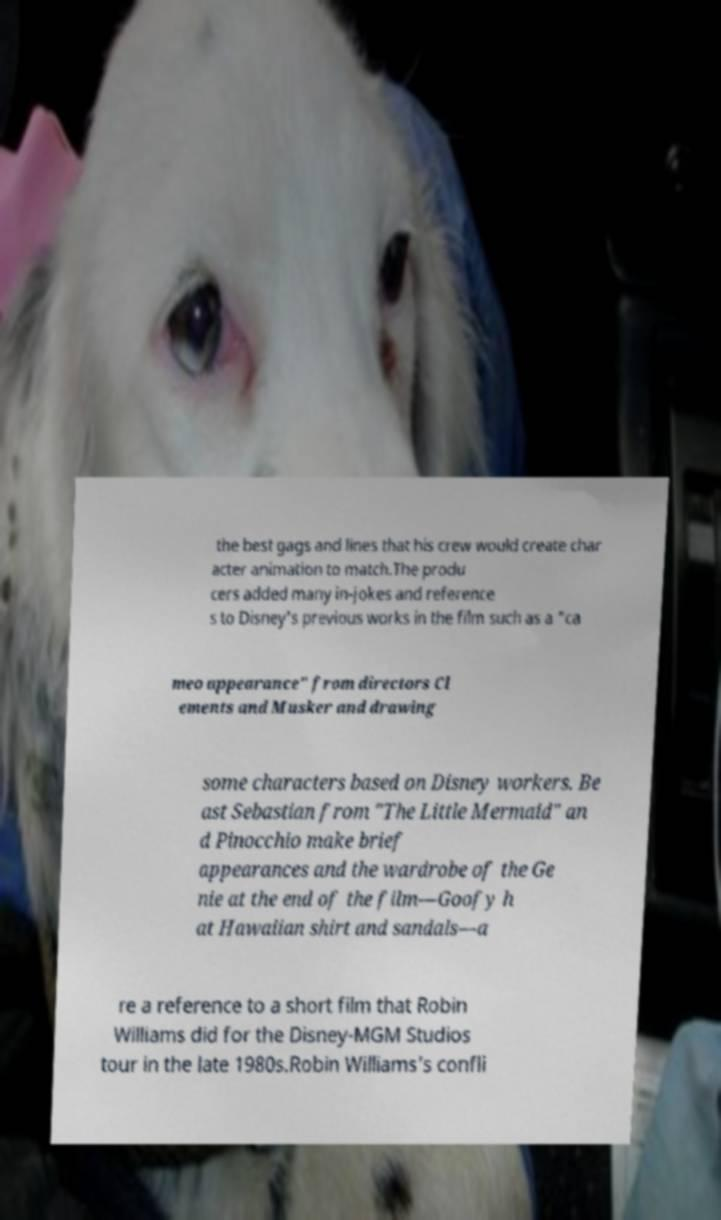Can you read and provide the text displayed in the image?This photo seems to have some interesting text. Can you extract and type it out for me? the best gags and lines that his crew would create char acter animation to match.The produ cers added many in-jokes and reference s to Disney's previous works in the film such as a "ca meo appearance" from directors Cl ements and Musker and drawing some characters based on Disney workers. Be ast Sebastian from "The Little Mermaid" an d Pinocchio make brief appearances and the wardrobe of the Ge nie at the end of the film—Goofy h at Hawaiian shirt and sandals—a re a reference to a short film that Robin Williams did for the Disney-MGM Studios tour in the late 1980s.Robin Williams's confli 